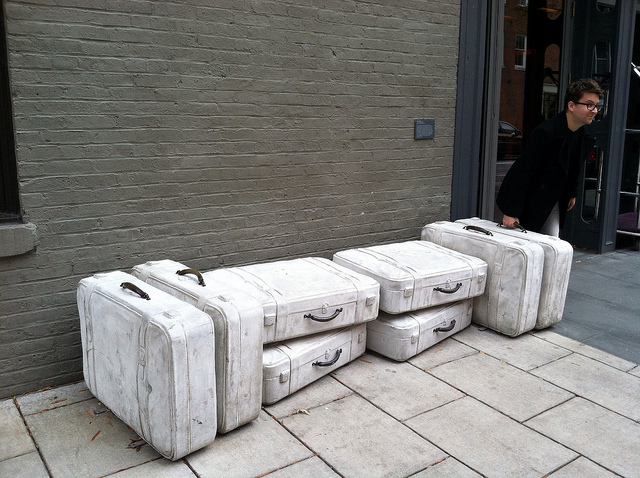<image>Who are the owners of the luggages? It is uncertain who the owners of the luggage are. It could be the man, the man with glasses, or the tourists. Who are the owners of the luggages? I don't know who the owners of the luggages are. It can be seen man, man with glasses, tourists, people or man in photo. 